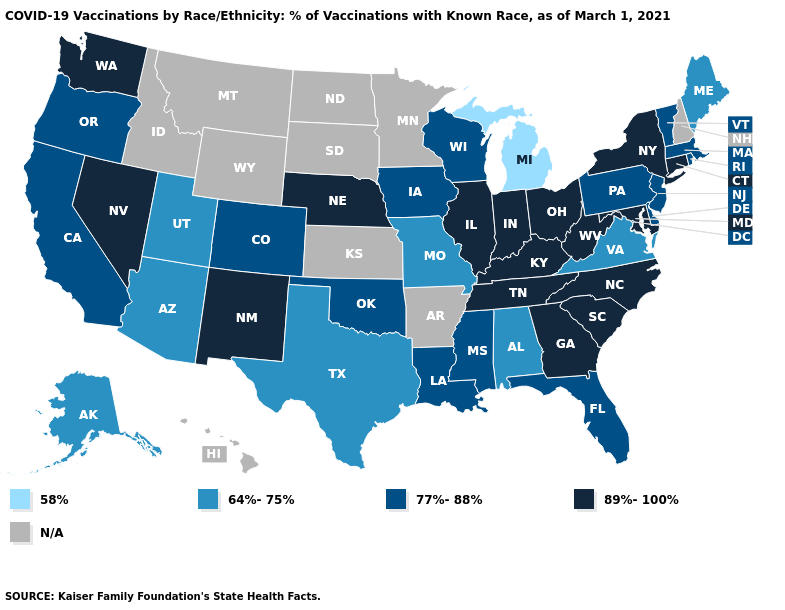What is the value of Oklahoma?
Answer briefly. 77%-88%. Name the states that have a value in the range 89%-100%?
Answer briefly. Connecticut, Georgia, Illinois, Indiana, Kentucky, Maryland, Nebraska, Nevada, New Mexico, New York, North Carolina, Ohio, South Carolina, Tennessee, Washington, West Virginia. What is the highest value in the Northeast ?
Write a very short answer. 89%-100%. What is the lowest value in the MidWest?
Short answer required. 58%. What is the value of West Virginia?
Short answer required. 89%-100%. Name the states that have a value in the range 77%-88%?
Keep it brief. California, Colorado, Delaware, Florida, Iowa, Louisiana, Massachusetts, Mississippi, New Jersey, Oklahoma, Oregon, Pennsylvania, Rhode Island, Vermont, Wisconsin. What is the value of New Jersey?
Keep it brief. 77%-88%. Does the map have missing data?
Concise answer only. Yes. Among the states that border Oregon , does Washington have the lowest value?
Quick response, please. No. Name the states that have a value in the range N/A?
Quick response, please. Arkansas, Hawaii, Idaho, Kansas, Minnesota, Montana, New Hampshire, North Dakota, South Dakota, Wyoming. Does Alaska have the highest value in the USA?
Answer briefly. No. 